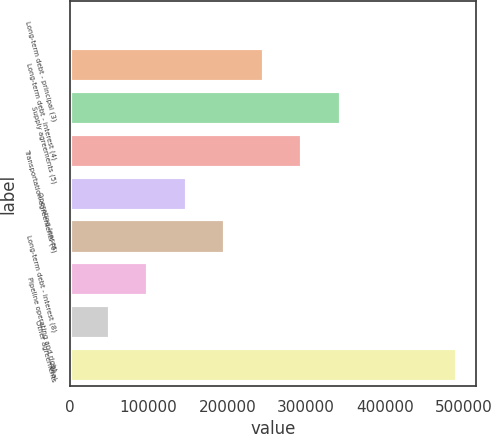Convert chart to OTSL. <chart><loc_0><loc_0><loc_500><loc_500><bar_chart><fcel>Long-term debt - principal (3)<fcel>Long-term debt - interest (4)<fcel>Supply agreements (5)<fcel>Transportation agreements (6)<fcel>Operating leases<fcel>Long-term debt - interest (8)<fcel>Pipeline operating and right<fcel>Other agreements<fcel>Total<nl><fcel>1477<fcel>246381<fcel>344343<fcel>295362<fcel>148419<fcel>197400<fcel>99438.6<fcel>50457.8<fcel>491285<nl></chart> 